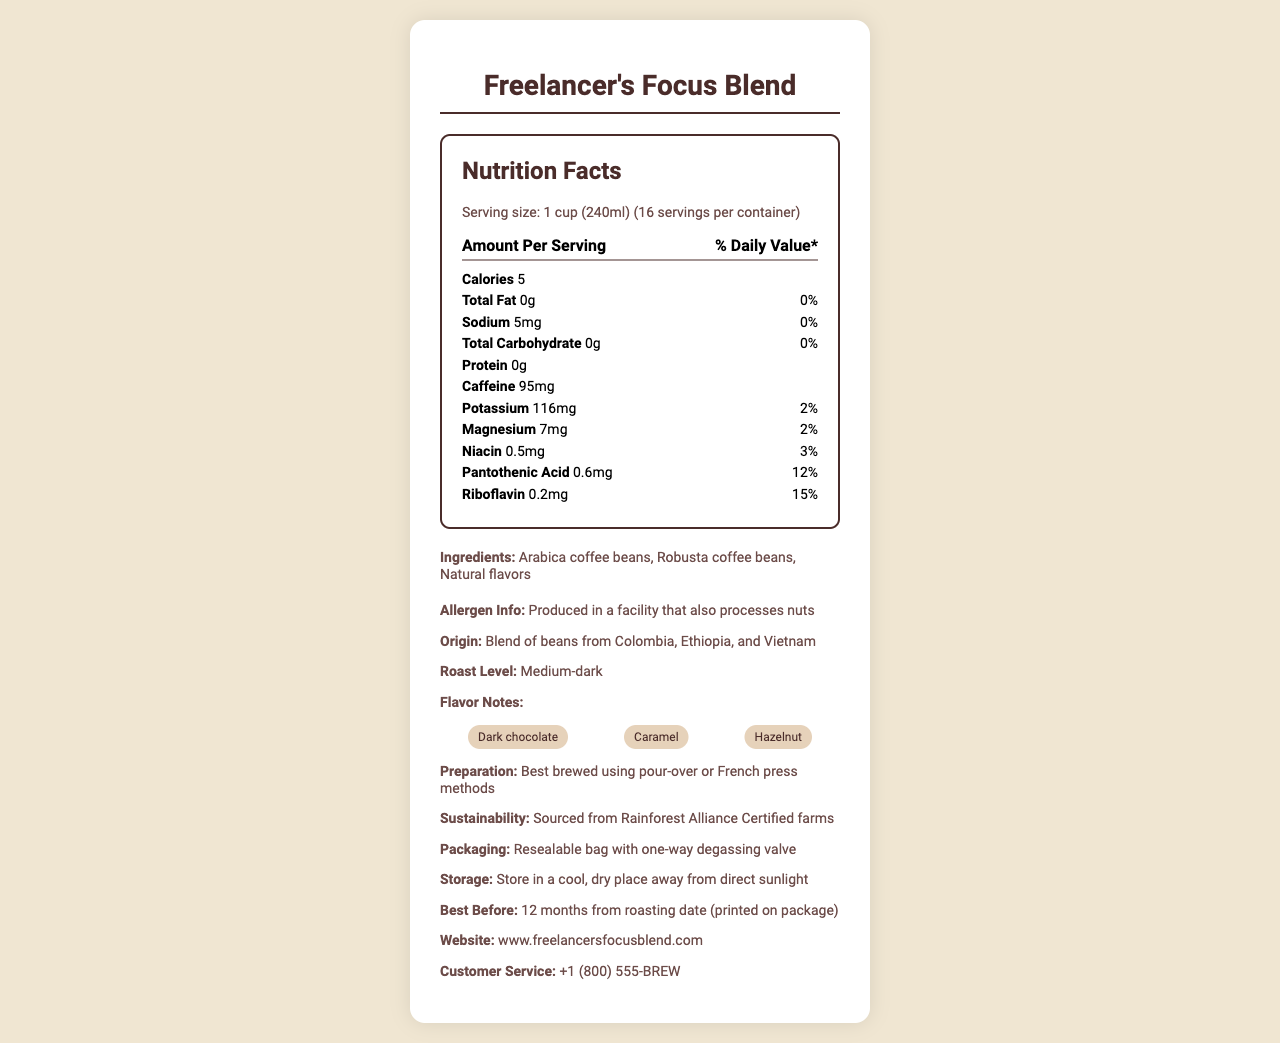what is the product name? The product name is displayed at the top of the document.
Answer: Freelancer's Focus Blend what is the serving size? The serving size is listed under the Nutrition Facts section.
Answer: 1 cup (240ml) how many calories are there per serving? The calorie count per serving is provided in the Nutrition Facts section.
Answer: 5 how much potassium does one serving contain? The amount of potassium per serving is listed in the Nutrition Facts section.
Answer: 116mg what are the main ingredients? The main ingredients are listed in the Ingredients section.
Answer: Arabica coffee beans, Robusta coffee beans, Natural flavors what is the caffeine content per serving? A. 50mg B. 75mg C. 95mg D. 110mg The caffeine content per serving is provided in the Nutrition Facts section.
Answer: C. 95mg which vitamin has the highest daily value percentage per serving? (a) Niacin (b) Pantothenic Acid (c) Riboflavin The riboflavin content has the highest daily value percentage per serving at 15%.
Answer: c) Riboflavin is the product produced in a facility that processes nuts? The allergen information states that it is produced in a facility that also processes nuts.
Answer: Yes does the document mention how to store the coffee? The storage instructions are given as "Store in a cool, dry place away from direct sunlight".
Answer: Yes summarize the key information about Freelancer's Focus Blend. The document provides a comprehensive overview including nutritional facts, ingredients, allergen information, preparation methods, sustainability, and storage instructions.
Answer: Freelancer's Focus Blend is a gourmet coffee blend with a serving size of 1 cup (240ml), containing 5 calories per serving. It has 95mg of caffeine and includes Arabica and Robusta coffee beans with natural flavors. The blend has vitamins such as niacin, pantothenic acid, and riboflavin. It is produced in a facility that processes nuts and is best brewed using pour-over or French press methods. It is sourced sustainably and should be stored in a cool, dry place. what is the percentage of daily value for sodium? The percentage of daily value for sodium is listed as 0%.
Answer: 0% what is the preparation method suggested for this coffee blend? The preparation method is specified in the additional information section.
Answer: Best brewed using pour-over or French press methods which of the following is not a flavor note mentioned in the document? A. Dark chocolate B. Hazelnut C. Vanilla The flavor notes mentioned are dark chocolate, caramel, and hazelnut. Vanilla is not listed.
Answer: C. Vanilla can we determine the price of the coffee from this document? The document does not provide any pricing information.
Answer: Not enough information from which countries are the coffee beans sourced? The origin information states that the coffee is a blend of beans from Colombia, Ethiopia, and Vietnam.
Answer: Colombia, Ethiopia, and Vietnam does the packaging feature a one-way degassing valve? The packaging has a resealable bag with a one-way degassing valve as mentioned in the additional information.
Answer: Yes 